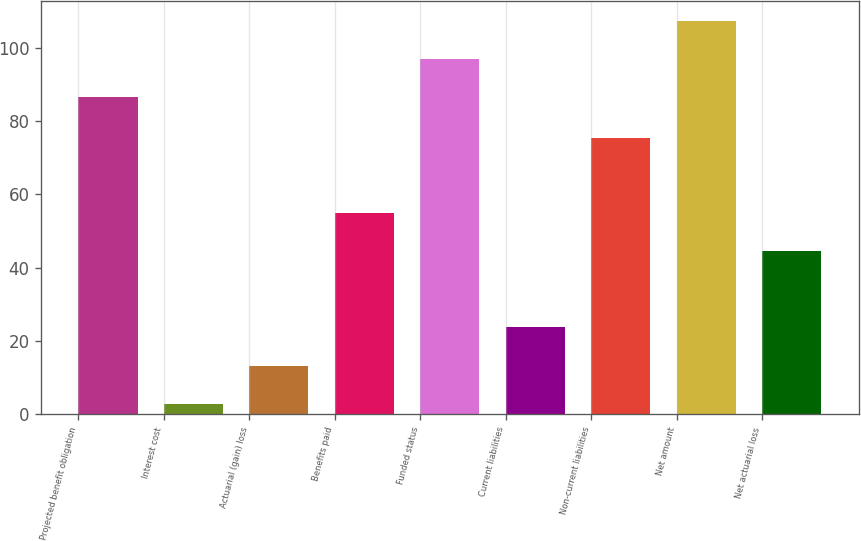Convert chart. <chart><loc_0><loc_0><loc_500><loc_500><bar_chart><fcel>Projected benefit obligation<fcel>Interest cost<fcel>Actuarial (gain) loss<fcel>Benefits paid<fcel>Funded status<fcel>Current liabilities<fcel>Non-current liabilities<fcel>Net amount<fcel>Net actuarial loss<nl><fcel>86.5<fcel>2.9<fcel>13.31<fcel>54.95<fcel>96.91<fcel>23.72<fcel>75.5<fcel>107.32<fcel>44.54<nl></chart> 